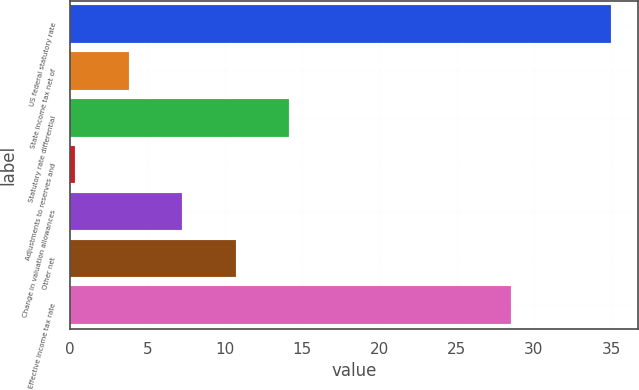Convert chart to OTSL. <chart><loc_0><loc_0><loc_500><loc_500><bar_chart><fcel>US federal statutory rate<fcel>State income tax net of<fcel>Statutory rate differential<fcel>Adjustments to reserves and<fcel>Change in valuation allowances<fcel>Other net<fcel>Effective income tax rate<nl><fcel>35<fcel>3.77<fcel>14.18<fcel>0.3<fcel>7.24<fcel>10.71<fcel>28.5<nl></chart> 